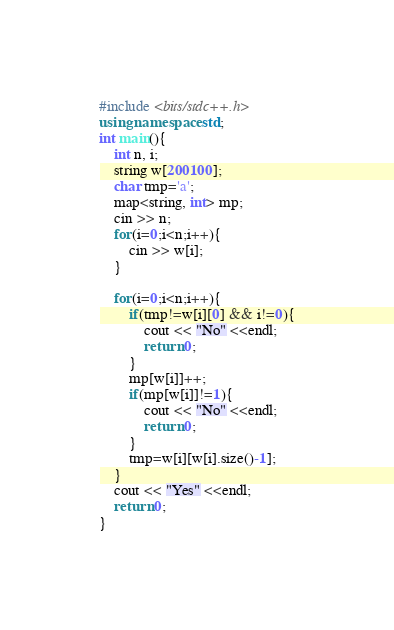Convert code to text. <code><loc_0><loc_0><loc_500><loc_500><_C++_>#include <bits/stdc++.h>
using namespace std;
int main(){
    int n, i;
    string w[200100];
    char tmp='a';
    map<string, int> mp;
    cin >> n;
    for(i=0;i<n;i++){
        cin >> w[i];
    }

    for(i=0;i<n;i++){
        if(tmp!=w[i][0] && i!=0){
            cout << "No" <<endl;
            return 0;
        }
        mp[w[i]]++;
        if(mp[w[i]]!=1){
            cout << "No" <<endl;
            return 0;
        }
        tmp=w[i][w[i].size()-1];
    }
    cout << "Yes" <<endl;
    return 0;
}
</code> 